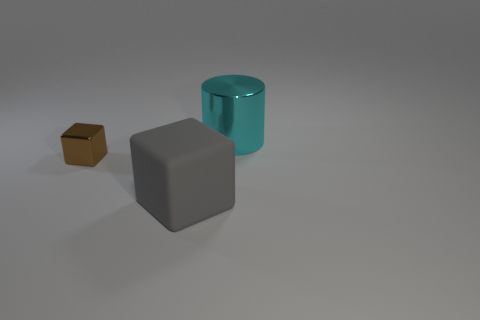Add 2 big gray matte blocks. How many objects exist? 5 Subtract all cubes. How many objects are left? 1 Subtract all tiny metal cubes. Subtract all green matte cylinders. How many objects are left? 2 Add 1 small brown metallic blocks. How many small brown metallic blocks are left? 2 Add 2 small yellow metallic cylinders. How many small yellow metallic cylinders exist? 2 Subtract 0 blue cubes. How many objects are left? 3 